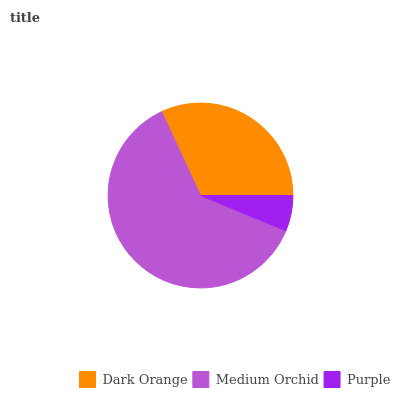Is Purple the minimum?
Answer yes or no. Yes. Is Medium Orchid the maximum?
Answer yes or no. Yes. Is Medium Orchid the minimum?
Answer yes or no. No. Is Purple the maximum?
Answer yes or no. No. Is Medium Orchid greater than Purple?
Answer yes or no. Yes. Is Purple less than Medium Orchid?
Answer yes or no. Yes. Is Purple greater than Medium Orchid?
Answer yes or no. No. Is Medium Orchid less than Purple?
Answer yes or no. No. Is Dark Orange the high median?
Answer yes or no. Yes. Is Dark Orange the low median?
Answer yes or no. Yes. Is Purple the high median?
Answer yes or no. No. Is Purple the low median?
Answer yes or no. No. 